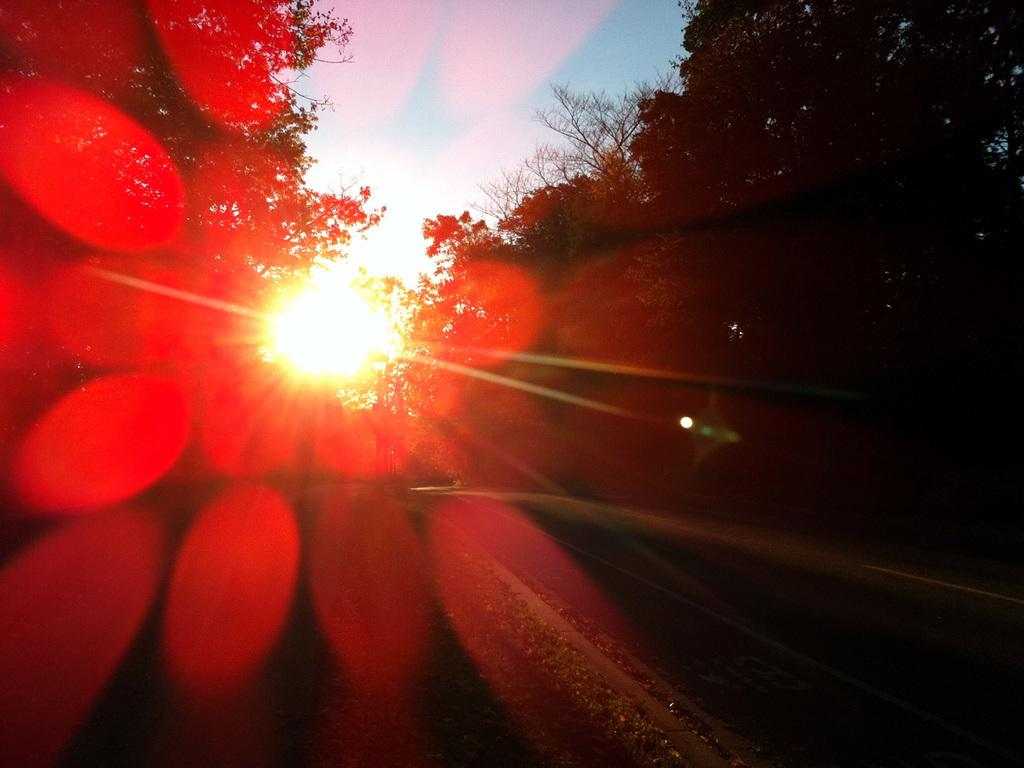What is located on the left side of the image? There is the sun on the left side of the image. How would you describe the sun in the image? The sun's light appears to be focused and has a red color. What type of vegetation can be seen in the image? There are trees in the image. What is visible at the top of the image? The sky is visible at the top of the image. Is there a woman holding an umbrella in the image? No, there is no woman or umbrella present in the image. Is it raining in the image? No, there is no indication of rain in the image. 